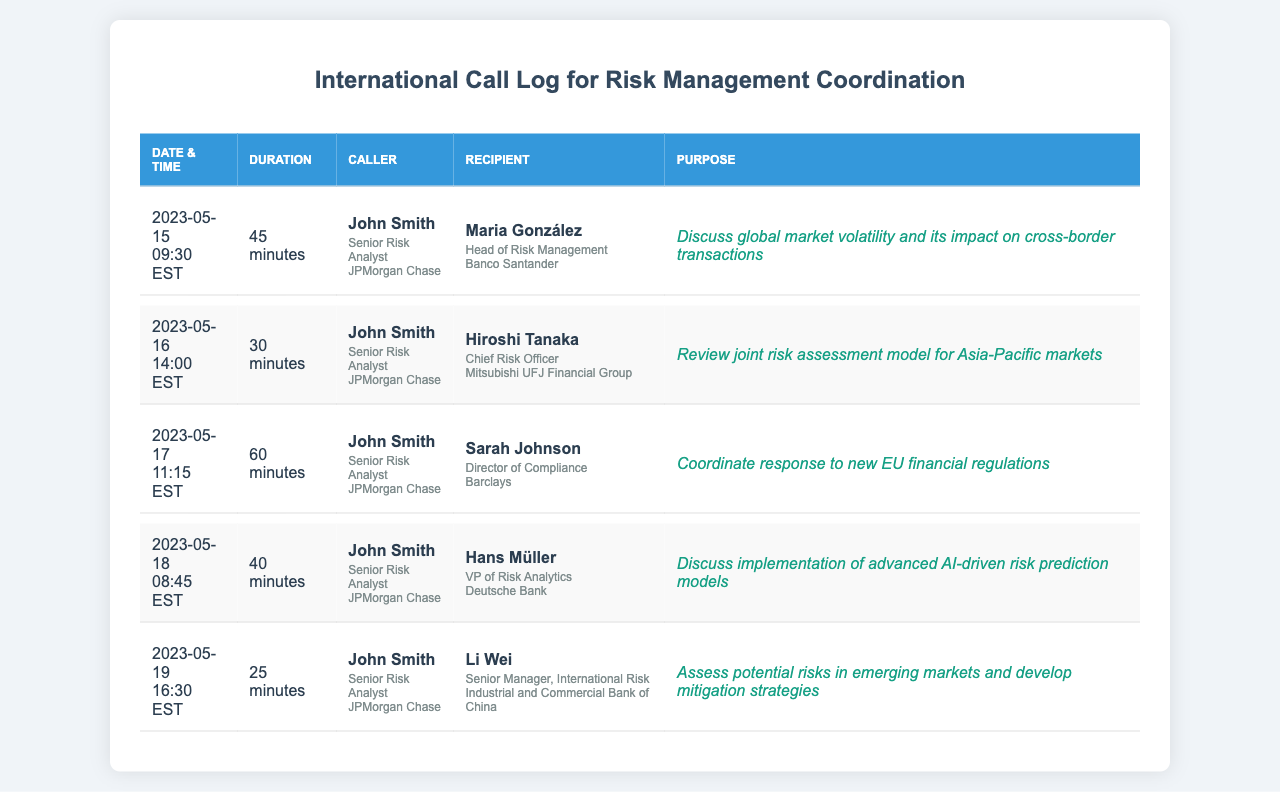What is the date of the call with Maria González? The call with Maria González took place on May 15, 2023.
Answer: May 15, 2023 Who is the caller for all listed calls? The caller for all the listed calls is John Smith.
Answer: John Smith What was the purpose of the call on May 19? The purpose of the call on May 19 was to assess potential risks in emerging markets and develop mitigation strategies.
Answer: Assess potential risks in emerging markets and develop mitigation strategies How long was the call with Hiroshi Tanaka? The call with Hiroshi Tanaka lasted for 30 minutes.
Answer: 30 minutes Which bank does Sarah Johnson work for? Sarah Johnson works for Barclays.
Answer: Barclays How many minutes did the longest call last? The longest call lasted for 60 minutes.
Answer: 60 minutes What position does Hans Müller hold? Hans Müller holds the position of VP of Risk Analytics.
Answer: VP of Risk Analytics What was discussed during the call on May 18? The discussion during the call on May 18 was about the implementation of advanced AI-driven risk prediction models.
Answer: Implementation of advanced AI-driven risk prediction models How many calls were made in total according to the log? There were five calls made in total according to the log.
Answer: Five 